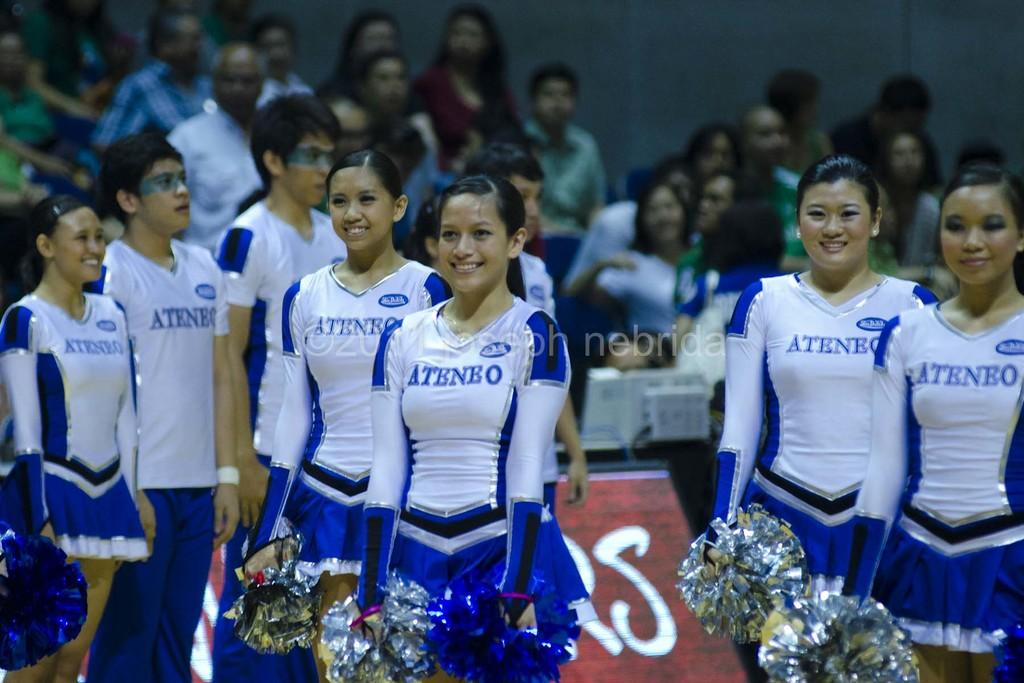<image>
Summarize the visual content of the image. A group of cheerleaders wearing shirts that say Ateneo on them. 